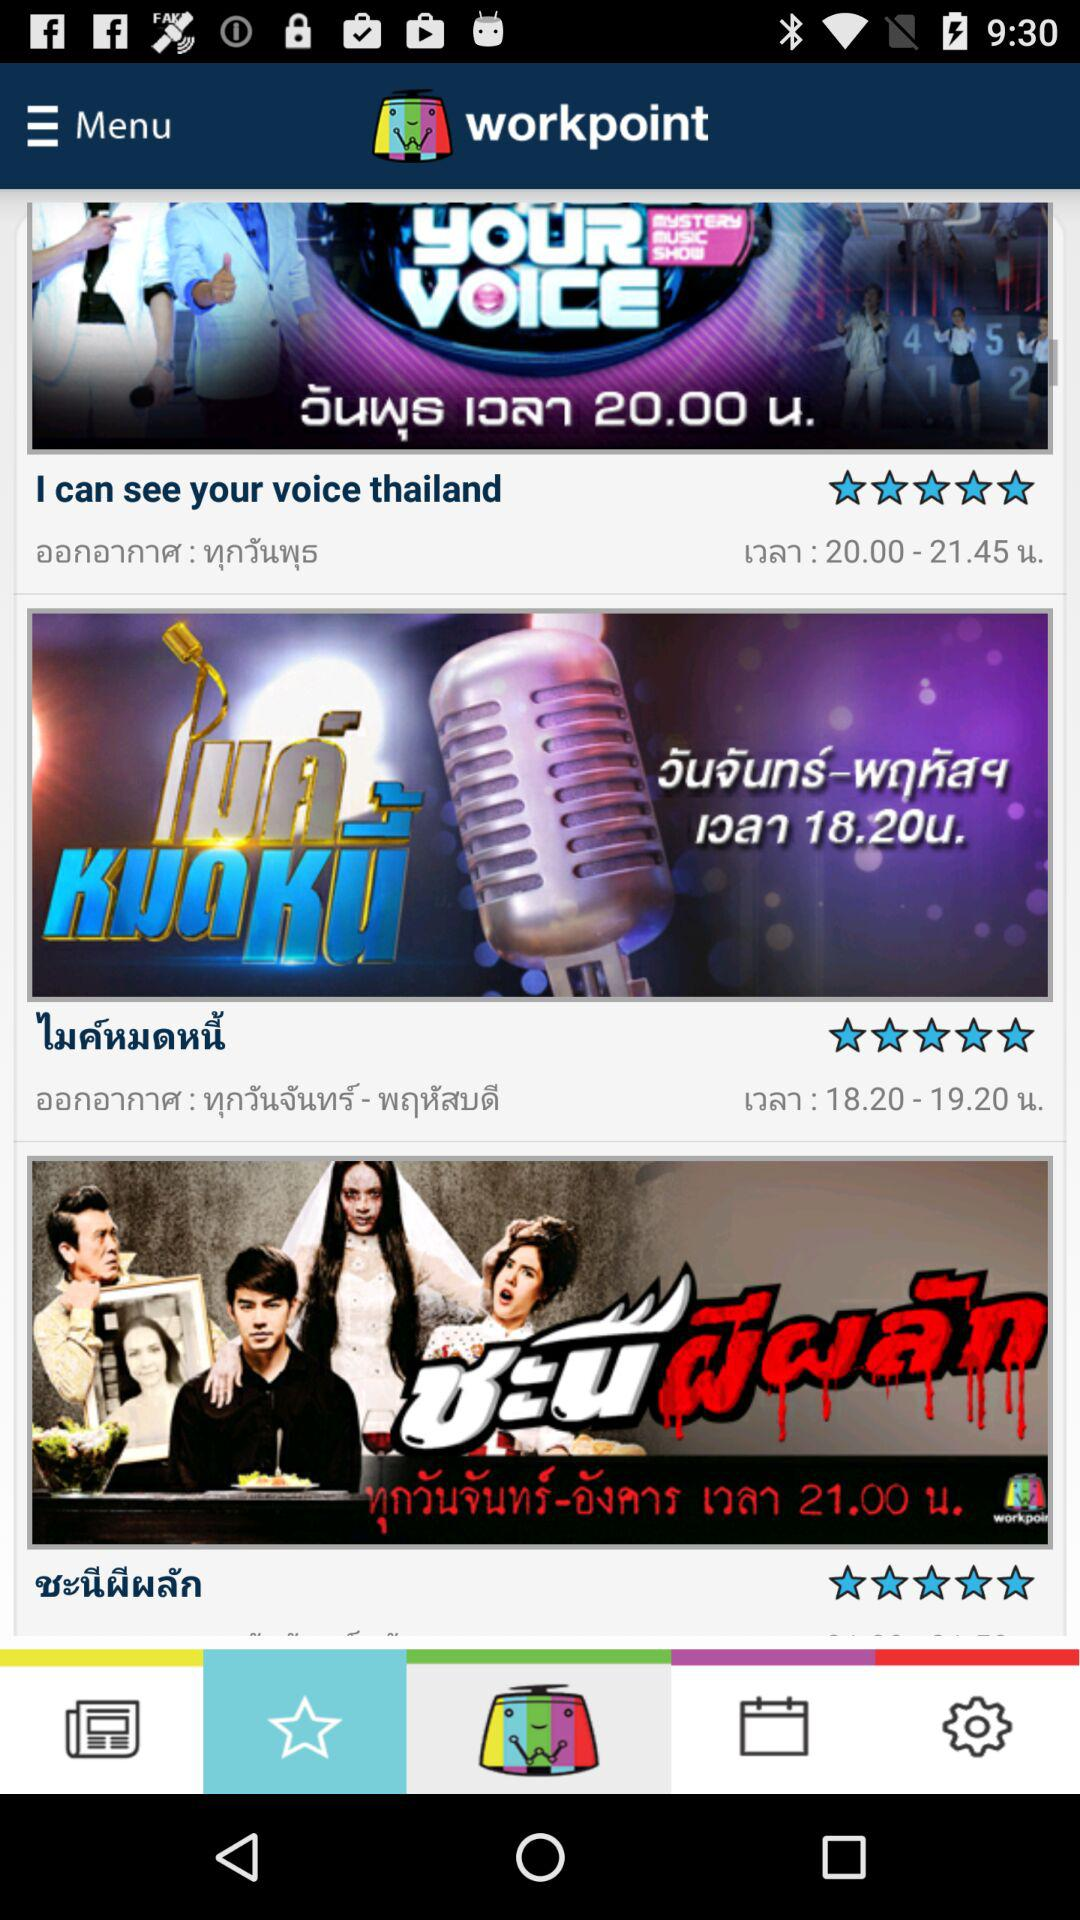How many shows are currently airing on this app?
Answer the question using a single word or phrase. 3 